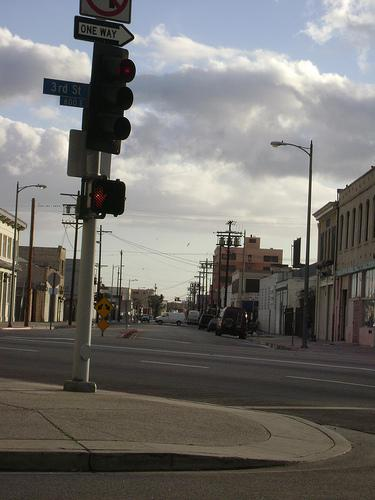Question: what is in the sky?
Choices:
A. Clouds.
B. Airplane.
C. Birds.
D. Kites.
Answer with the letter. Answer: A Question: what street is this one?
Choices:
A. Wilson Ave.
B. 3rd St.
C. Charleston Blvd.
D. Laurel Lane.
Answer with the letter. Answer: B Question: how many people are in the photo?
Choices:
A. None.
B. Two.
C. Three.
D. Four.
Answer with the letter. Answer: A Question: what does the black and white sign say?
Choices:
A. No Parking.
B. Speed Limit 55.
C. One way.
D. Tow Away Zone.
Answer with the letter. Answer: C 